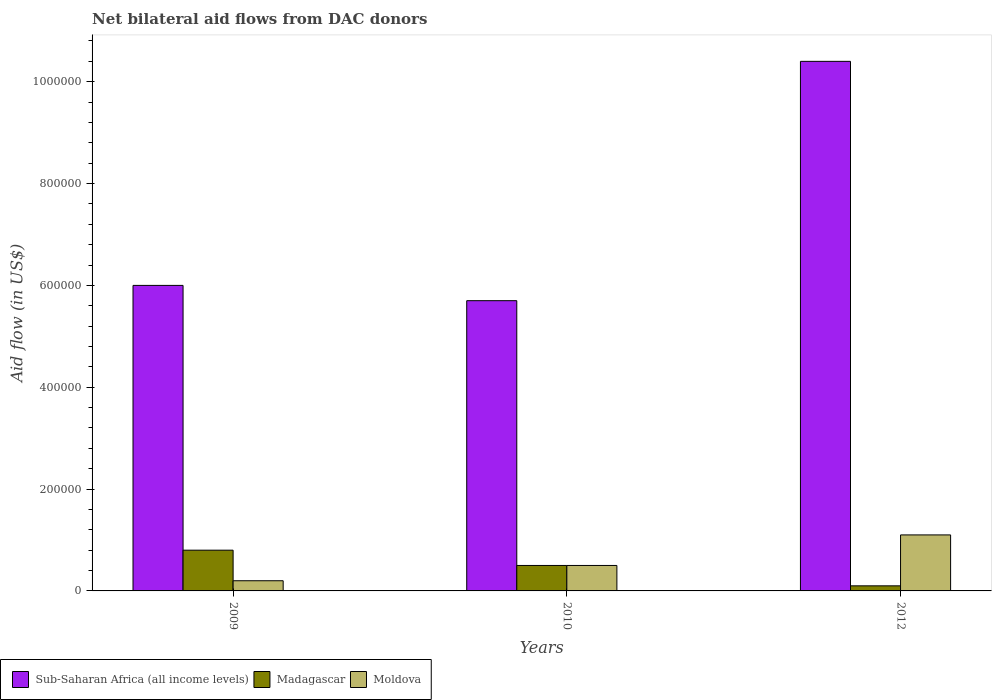How many different coloured bars are there?
Offer a terse response. 3. How many groups of bars are there?
Ensure brevity in your answer.  3. Are the number of bars per tick equal to the number of legend labels?
Ensure brevity in your answer.  Yes. Are the number of bars on each tick of the X-axis equal?
Make the answer very short. Yes. How many bars are there on the 3rd tick from the left?
Give a very brief answer. 3. How many bars are there on the 3rd tick from the right?
Offer a terse response. 3. Across all years, what is the maximum net bilateral aid flow in Sub-Saharan Africa (all income levels)?
Your response must be concise. 1.04e+06. Across all years, what is the minimum net bilateral aid flow in Sub-Saharan Africa (all income levels)?
Keep it short and to the point. 5.70e+05. In which year was the net bilateral aid flow in Sub-Saharan Africa (all income levels) maximum?
Ensure brevity in your answer.  2012. In which year was the net bilateral aid flow in Moldova minimum?
Your answer should be compact. 2009. What is the total net bilateral aid flow in Moldova in the graph?
Give a very brief answer. 1.80e+05. What is the difference between the net bilateral aid flow in Madagascar in 2010 and that in 2012?
Provide a short and direct response. 4.00e+04. What is the difference between the net bilateral aid flow in Moldova in 2010 and the net bilateral aid flow in Sub-Saharan Africa (all income levels) in 2009?
Your response must be concise. -5.50e+05. What is the average net bilateral aid flow in Moldova per year?
Provide a succinct answer. 6.00e+04. In the year 2010, what is the difference between the net bilateral aid flow in Madagascar and net bilateral aid flow in Sub-Saharan Africa (all income levels)?
Offer a terse response. -5.20e+05. In how many years, is the net bilateral aid flow in Moldova greater than 680000 US$?
Keep it short and to the point. 0. What is the ratio of the net bilateral aid flow in Moldova in 2010 to that in 2012?
Provide a short and direct response. 0.45. Is the net bilateral aid flow in Sub-Saharan Africa (all income levels) in 2010 less than that in 2012?
Make the answer very short. Yes. What is the difference between the highest and the second highest net bilateral aid flow in Moldova?
Provide a short and direct response. 6.00e+04. What does the 1st bar from the left in 2010 represents?
Your answer should be very brief. Sub-Saharan Africa (all income levels). What does the 3rd bar from the right in 2009 represents?
Make the answer very short. Sub-Saharan Africa (all income levels). Is it the case that in every year, the sum of the net bilateral aid flow in Sub-Saharan Africa (all income levels) and net bilateral aid flow in Madagascar is greater than the net bilateral aid flow in Moldova?
Provide a short and direct response. Yes. How many bars are there?
Provide a short and direct response. 9. Are all the bars in the graph horizontal?
Provide a short and direct response. No. How many years are there in the graph?
Offer a terse response. 3. What is the difference between two consecutive major ticks on the Y-axis?
Make the answer very short. 2.00e+05. Are the values on the major ticks of Y-axis written in scientific E-notation?
Make the answer very short. No. Does the graph contain any zero values?
Your answer should be very brief. No. Does the graph contain grids?
Your response must be concise. No. How many legend labels are there?
Make the answer very short. 3. How are the legend labels stacked?
Give a very brief answer. Horizontal. What is the title of the graph?
Offer a terse response. Net bilateral aid flows from DAC donors. Does "Trinidad and Tobago" appear as one of the legend labels in the graph?
Provide a succinct answer. No. What is the label or title of the X-axis?
Offer a very short reply. Years. What is the label or title of the Y-axis?
Your answer should be very brief. Aid flow (in US$). What is the Aid flow (in US$) in Sub-Saharan Africa (all income levels) in 2009?
Give a very brief answer. 6.00e+05. What is the Aid flow (in US$) in Moldova in 2009?
Make the answer very short. 2.00e+04. What is the Aid flow (in US$) of Sub-Saharan Africa (all income levels) in 2010?
Keep it short and to the point. 5.70e+05. What is the Aid flow (in US$) in Sub-Saharan Africa (all income levels) in 2012?
Your answer should be compact. 1.04e+06. What is the Aid flow (in US$) of Madagascar in 2012?
Provide a short and direct response. 10000. What is the Aid flow (in US$) of Moldova in 2012?
Offer a terse response. 1.10e+05. Across all years, what is the maximum Aid flow (in US$) of Sub-Saharan Africa (all income levels)?
Offer a very short reply. 1.04e+06. Across all years, what is the maximum Aid flow (in US$) in Madagascar?
Offer a very short reply. 8.00e+04. Across all years, what is the maximum Aid flow (in US$) in Moldova?
Offer a terse response. 1.10e+05. Across all years, what is the minimum Aid flow (in US$) in Sub-Saharan Africa (all income levels)?
Provide a succinct answer. 5.70e+05. What is the total Aid flow (in US$) of Sub-Saharan Africa (all income levels) in the graph?
Keep it short and to the point. 2.21e+06. What is the total Aid flow (in US$) in Madagascar in the graph?
Provide a succinct answer. 1.40e+05. What is the total Aid flow (in US$) of Moldova in the graph?
Provide a succinct answer. 1.80e+05. What is the difference between the Aid flow (in US$) in Sub-Saharan Africa (all income levels) in 2009 and that in 2012?
Give a very brief answer. -4.40e+05. What is the difference between the Aid flow (in US$) of Madagascar in 2009 and that in 2012?
Your answer should be compact. 7.00e+04. What is the difference between the Aid flow (in US$) in Sub-Saharan Africa (all income levels) in 2010 and that in 2012?
Provide a short and direct response. -4.70e+05. What is the difference between the Aid flow (in US$) of Madagascar in 2010 and that in 2012?
Keep it short and to the point. 4.00e+04. What is the difference between the Aid flow (in US$) of Moldova in 2010 and that in 2012?
Provide a succinct answer. -6.00e+04. What is the difference between the Aid flow (in US$) in Madagascar in 2009 and the Aid flow (in US$) in Moldova in 2010?
Offer a very short reply. 3.00e+04. What is the difference between the Aid flow (in US$) of Sub-Saharan Africa (all income levels) in 2009 and the Aid flow (in US$) of Madagascar in 2012?
Ensure brevity in your answer.  5.90e+05. What is the difference between the Aid flow (in US$) in Sub-Saharan Africa (all income levels) in 2009 and the Aid flow (in US$) in Moldova in 2012?
Make the answer very short. 4.90e+05. What is the difference between the Aid flow (in US$) in Sub-Saharan Africa (all income levels) in 2010 and the Aid flow (in US$) in Madagascar in 2012?
Your response must be concise. 5.60e+05. What is the average Aid flow (in US$) in Sub-Saharan Africa (all income levels) per year?
Your answer should be compact. 7.37e+05. What is the average Aid flow (in US$) in Madagascar per year?
Give a very brief answer. 4.67e+04. In the year 2009, what is the difference between the Aid flow (in US$) of Sub-Saharan Africa (all income levels) and Aid flow (in US$) of Madagascar?
Keep it short and to the point. 5.20e+05. In the year 2009, what is the difference between the Aid flow (in US$) of Sub-Saharan Africa (all income levels) and Aid flow (in US$) of Moldova?
Give a very brief answer. 5.80e+05. In the year 2009, what is the difference between the Aid flow (in US$) of Madagascar and Aid flow (in US$) of Moldova?
Ensure brevity in your answer.  6.00e+04. In the year 2010, what is the difference between the Aid flow (in US$) in Sub-Saharan Africa (all income levels) and Aid flow (in US$) in Madagascar?
Your answer should be very brief. 5.20e+05. In the year 2010, what is the difference between the Aid flow (in US$) of Sub-Saharan Africa (all income levels) and Aid flow (in US$) of Moldova?
Your response must be concise. 5.20e+05. In the year 2010, what is the difference between the Aid flow (in US$) of Madagascar and Aid flow (in US$) of Moldova?
Provide a succinct answer. 0. In the year 2012, what is the difference between the Aid flow (in US$) in Sub-Saharan Africa (all income levels) and Aid flow (in US$) in Madagascar?
Offer a very short reply. 1.03e+06. In the year 2012, what is the difference between the Aid flow (in US$) in Sub-Saharan Africa (all income levels) and Aid flow (in US$) in Moldova?
Offer a terse response. 9.30e+05. In the year 2012, what is the difference between the Aid flow (in US$) of Madagascar and Aid flow (in US$) of Moldova?
Your answer should be compact. -1.00e+05. What is the ratio of the Aid flow (in US$) in Sub-Saharan Africa (all income levels) in 2009 to that in 2010?
Your answer should be very brief. 1.05. What is the ratio of the Aid flow (in US$) of Madagascar in 2009 to that in 2010?
Offer a terse response. 1.6. What is the ratio of the Aid flow (in US$) in Sub-Saharan Africa (all income levels) in 2009 to that in 2012?
Your response must be concise. 0.58. What is the ratio of the Aid flow (in US$) in Moldova in 2009 to that in 2012?
Keep it short and to the point. 0.18. What is the ratio of the Aid flow (in US$) in Sub-Saharan Africa (all income levels) in 2010 to that in 2012?
Your response must be concise. 0.55. What is the ratio of the Aid flow (in US$) in Moldova in 2010 to that in 2012?
Offer a terse response. 0.45. What is the difference between the highest and the second highest Aid flow (in US$) in Moldova?
Your answer should be very brief. 6.00e+04. What is the difference between the highest and the lowest Aid flow (in US$) of Sub-Saharan Africa (all income levels)?
Give a very brief answer. 4.70e+05. 